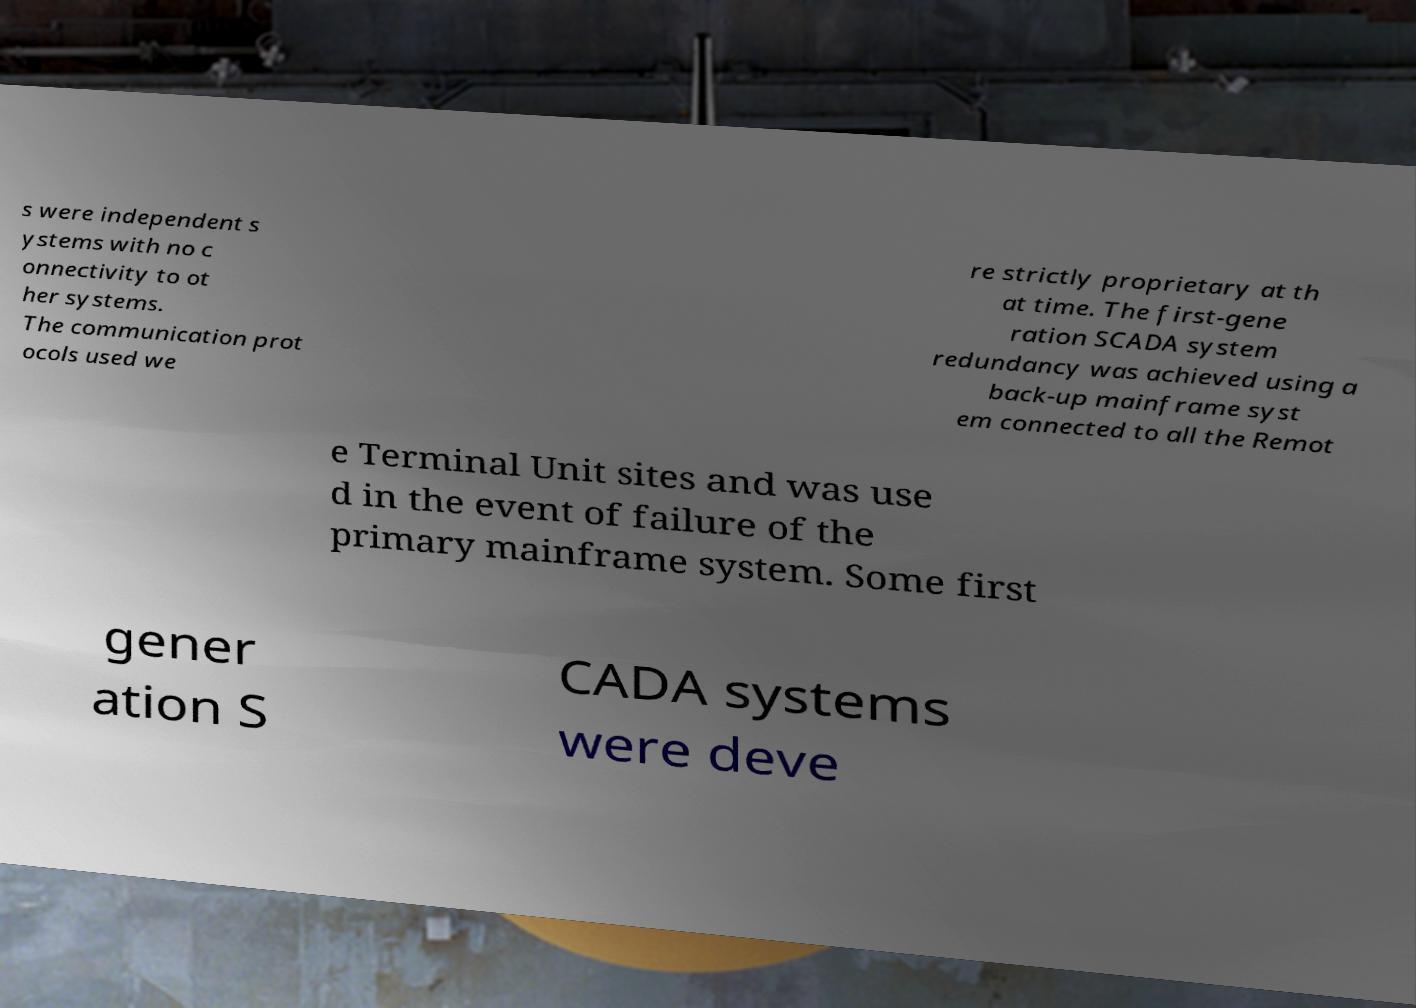Can you accurately transcribe the text from the provided image for me? s were independent s ystems with no c onnectivity to ot her systems. The communication prot ocols used we re strictly proprietary at th at time. The first-gene ration SCADA system redundancy was achieved using a back-up mainframe syst em connected to all the Remot e Terminal Unit sites and was use d in the event of failure of the primary mainframe system. Some first gener ation S CADA systems were deve 